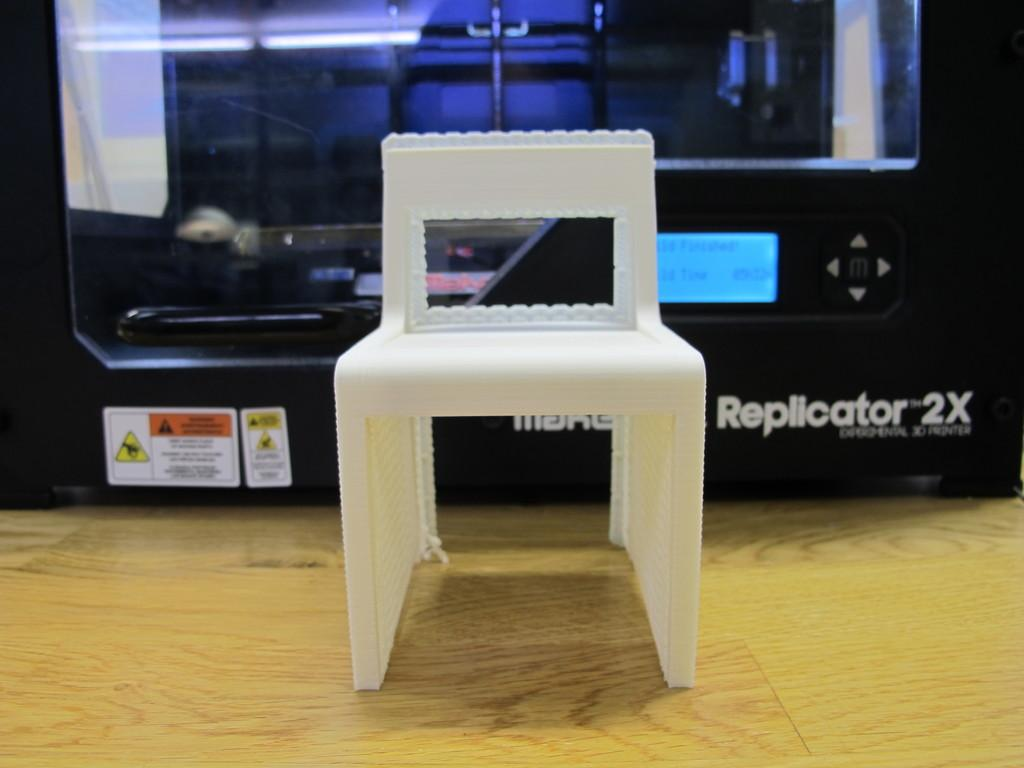What is the main object in the center of the image? There is a chair in the center of the image. What can be seen behind the chair? There is a black color cabin behind the chair. What type of flooring is visible at the bottom of the image? There is a wooden floor at the bottom of the image. What type of unit is being turned on in the image? There is no unit being turned on in the image; it only features a chair, a black color cabin, and a wooden floor. What kind of apparel is the chair wearing in the image? Chairs do not wear apparel, so this question cannot be answered. 